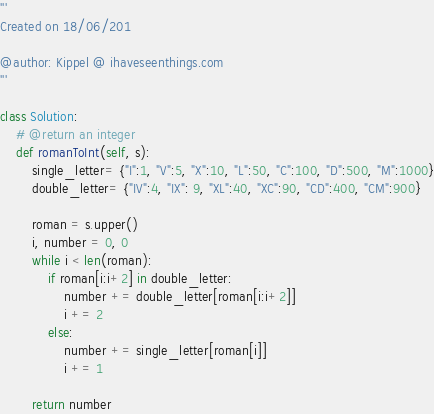Convert code to text. <code><loc_0><loc_0><loc_500><loc_500><_Python_>'''
Created on 18/06/201

@author: Kippel @ ihaveseenthings.com
'''

class Solution:
    # @return an integer
    def romanToInt(self, s):
        single_letter= {"I":1, "V":5, "X":10, "L":50, "C":100, "D":500, "M":1000}
        double_letter= {"IV":4, "IX": 9, "XL":40, "XC":90, "CD":400, "CM":900}
    
        roman = s.upper()
        i, number = 0, 0
        while i < len(roman):
            if roman[i:i+2] in double_letter:
                number += double_letter[roman[i:i+2]]
                i += 2
            else:
                number += single_letter[roman[i]]
                i += 1
    
        return number</code> 